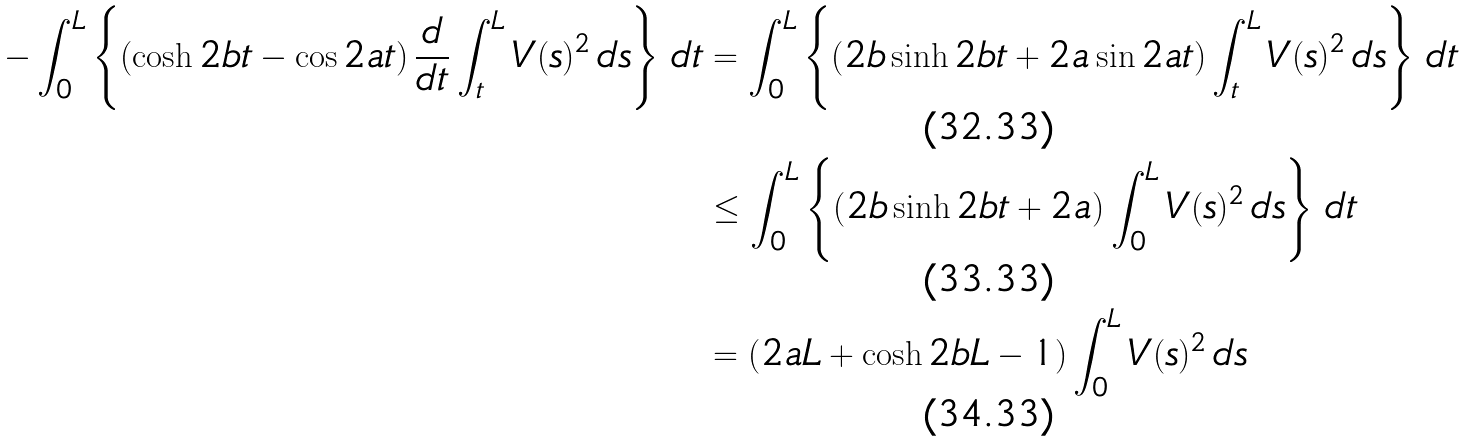<formula> <loc_0><loc_0><loc_500><loc_500>- \int _ { 0 } ^ { L } \left \{ \left ( \cosh 2 b t - \cos 2 a t \right ) \frac { d } { d t } \int _ { t } ^ { L } V ( s ) ^ { 2 } \, d s \right \} \, d t & = \int _ { 0 } ^ { L } \left \{ \left ( 2 b \sinh 2 b t + 2 a \sin 2 a t \right ) \int _ { t } ^ { L } V ( s ) ^ { 2 } \, d s \right \} \, d t \\ & \leq \int _ { 0 } ^ { L } \left \{ \left ( 2 b \sinh 2 b t + 2 a \right ) \int _ { 0 } ^ { L } V ( s ) ^ { 2 } \, d s \right \} \, d t \\ & = \left ( 2 a L + \cosh 2 b L - 1 \right ) \int _ { 0 } ^ { L } V ( s ) ^ { 2 } \, d s</formula> 